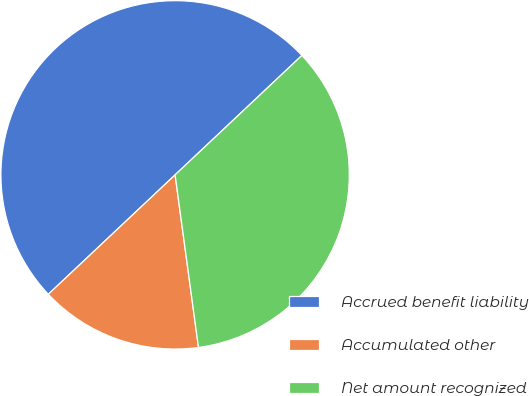Convert chart to OTSL. <chart><loc_0><loc_0><loc_500><loc_500><pie_chart><fcel>Accrued benefit liability<fcel>Accumulated other<fcel>Net amount recognized<nl><fcel>50.0%<fcel>15.12%<fcel>34.88%<nl></chart> 